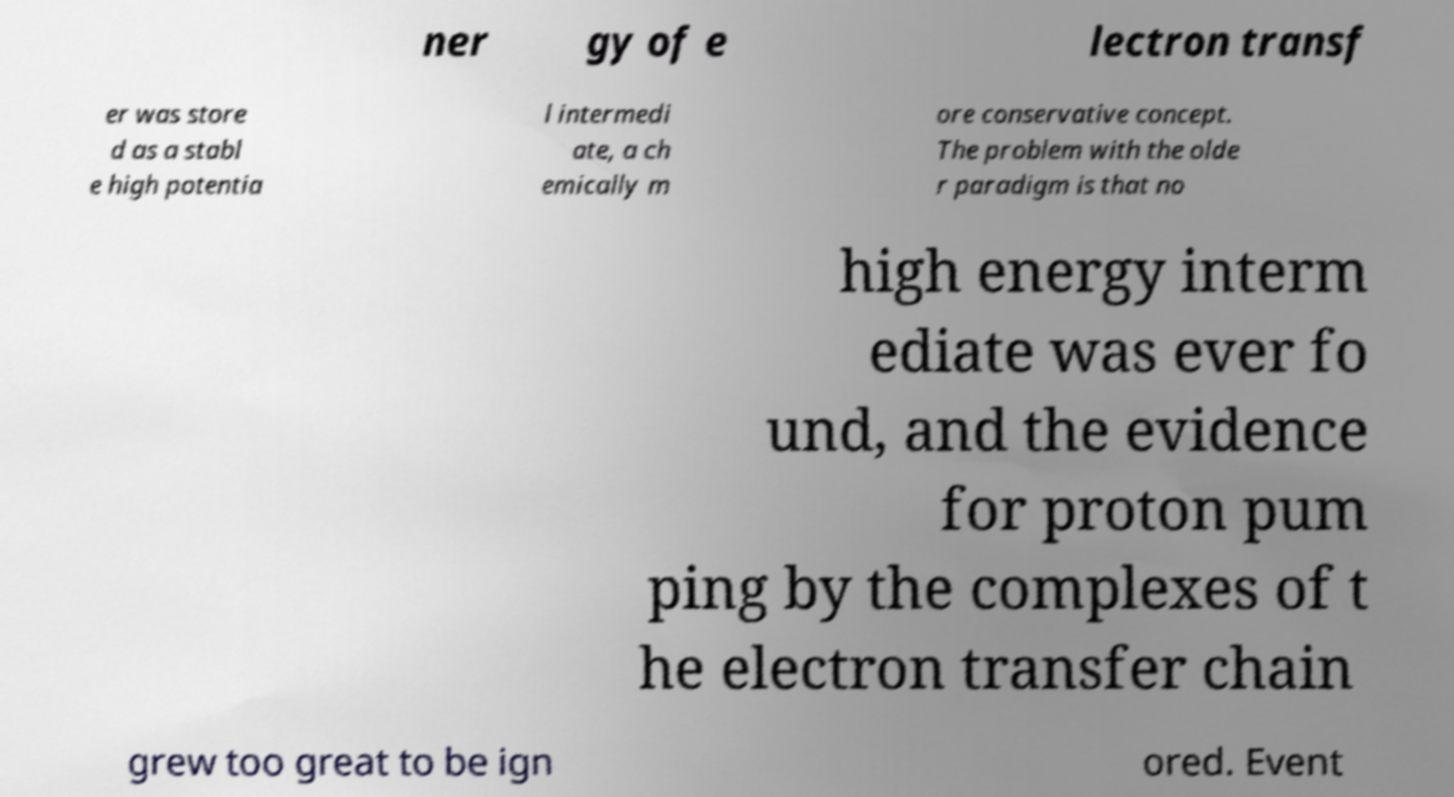What messages or text are displayed in this image? I need them in a readable, typed format. ner gy of e lectron transf er was store d as a stabl e high potentia l intermedi ate, a ch emically m ore conservative concept. The problem with the olde r paradigm is that no high energy interm ediate was ever fo und, and the evidence for proton pum ping by the complexes of t he electron transfer chain grew too great to be ign ored. Event 